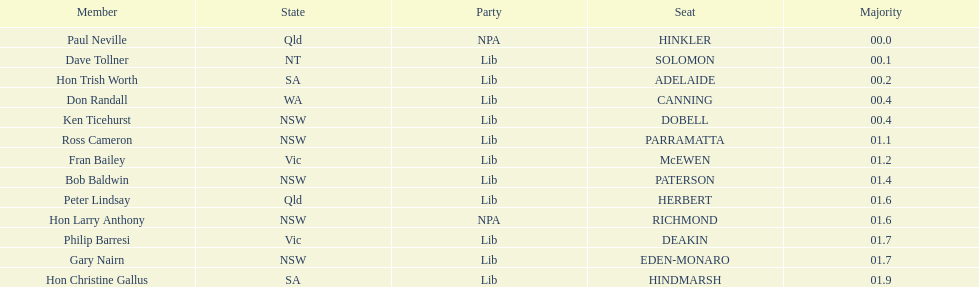How many states were represented in the seats? 6. 